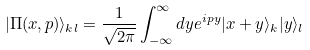<formula> <loc_0><loc_0><loc_500><loc_500>| \Pi ( x , p ) \rangle _ { k l } = \frac { 1 } { \sqrt { 2 \pi } } \int _ { - \infty } ^ { \infty } d y e ^ { i p y } | x + y \rangle _ { k } | y \rangle _ { l }</formula> 